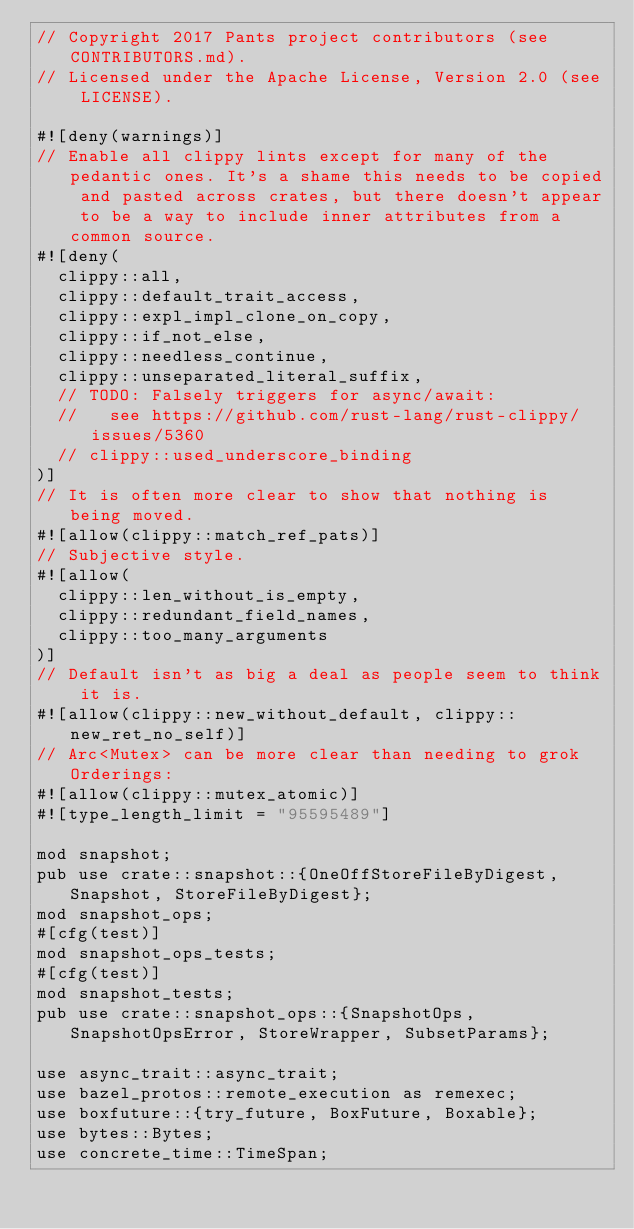<code> <loc_0><loc_0><loc_500><loc_500><_Rust_>// Copyright 2017 Pants project contributors (see CONTRIBUTORS.md).
// Licensed under the Apache License, Version 2.0 (see LICENSE).

#![deny(warnings)]
// Enable all clippy lints except for many of the pedantic ones. It's a shame this needs to be copied and pasted across crates, but there doesn't appear to be a way to include inner attributes from a common source.
#![deny(
  clippy::all,
  clippy::default_trait_access,
  clippy::expl_impl_clone_on_copy,
  clippy::if_not_else,
  clippy::needless_continue,
  clippy::unseparated_literal_suffix,
  // TODO: Falsely triggers for async/await:
  //   see https://github.com/rust-lang/rust-clippy/issues/5360
  // clippy::used_underscore_binding
)]
// It is often more clear to show that nothing is being moved.
#![allow(clippy::match_ref_pats)]
// Subjective style.
#![allow(
  clippy::len_without_is_empty,
  clippy::redundant_field_names,
  clippy::too_many_arguments
)]
// Default isn't as big a deal as people seem to think it is.
#![allow(clippy::new_without_default, clippy::new_ret_no_self)]
// Arc<Mutex> can be more clear than needing to grok Orderings:
#![allow(clippy::mutex_atomic)]
#![type_length_limit = "95595489"]

mod snapshot;
pub use crate::snapshot::{OneOffStoreFileByDigest, Snapshot, StoreFileByDigest};
mod snapshot_ops;
#[cfg(test)]
mod snapshot_ops_tests;
#[cfg(test)]
mod snapshot_tests;
pub use crate::snapshot_ops::{SnapshotOps, SnapshotOpsError, StoreWrapper, SubsetParams};

use async_trait::async_trait;
use bazel_protos::remote_execution as remexec;
use boxfuture::{try_future, BoxFuture, Boxable};
use bytes::Bytes;
use concrete_time::TimeSpan;</code> 